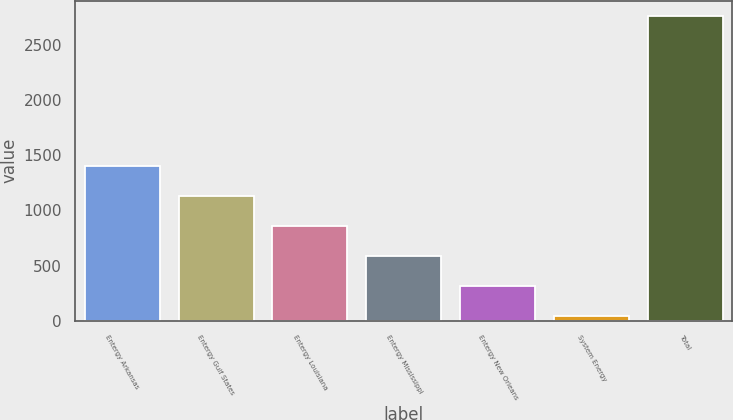Convert chart to OTSL. <chart><loc_0><loc_0><loc_500><loc_500><bar_chart><fcel>Entergy Arkansas<fcel>Entergy Gulf States<fcel>Entergy Louisiana<fcel>Entergy Mississippi<fcel>Entergy New Orleans<fcel>System Energy<fcel>Total<nl><fcel>1405<fcel>1133.4<fcel>861.8<fcel>590.2<fcel>318.6<fcel>47<fcel>2763<nl></chart> 